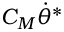Convert formula to latex. <formula><loc_0><loc_0><loc_500><loc_500>C _ { M } \dot { \theta } ^ { * }</formula> 